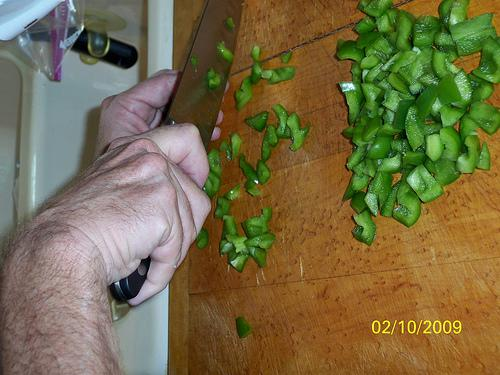Question: what color are the peppers?
Choices:
A. Red.
B. Orange.
C. Green.
D. Yellow.
Answer with the letter. Answer: C Question: what is the man holding?
Choices:
A. An axe.
B. A knife.
C. A fork.
D. A spoon.
Answer with the letter. Answer: B Question: when was the photo taken?
Choices:
A. 2/10/2010.
B. 2/09/2009.
C. 2/11/2009.
D. 02/10/2009.
Answer with the letter. Answer: D Question: what surface is the man cutting on?
Choices:
A. Metal.
B. Iron.
C. Wood.
D. Oak.
Answer with the letter. Answer: C 